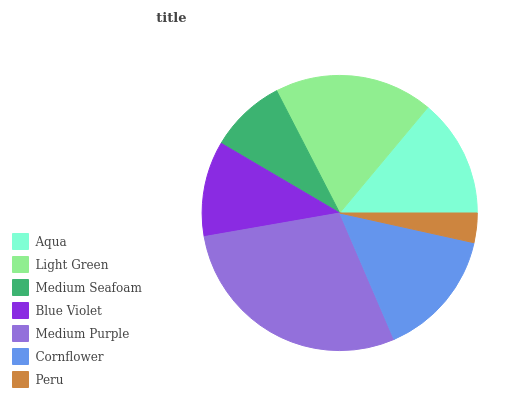Is Peru the minimum?
Answer yes or no. Yes. Is Medium Purple the maximum?
Answer yes or no. Yes. Is Light Green the minimum?
Answer yes or no. No. Is Light Green the maximum?
Answer yes or no. No. Is Light Green greater than Aqua?
Answer yes or no. Yes. Is Aqua less than Light Green?
Answer yes or no. Yes. Is Aqua greater than Light Green?
Answer yes or no. No. Is Light Green less than Aqua?
Answer yes or no. No. Is Aqua the high median?
Answer yes or no. Yes. Is Aqua the low median?
Answer yes or no. Yes. Is Peru the high median?
Answer yes or no. No. Is Medium Seafoam the low median?
Answer yes or no. No. 